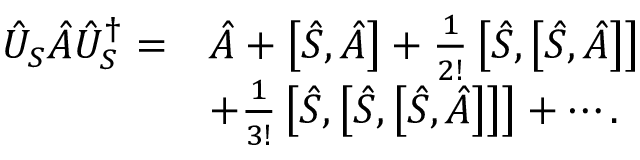Convert formula to latex. <formula><loc_0><loc_0><loc_500><loc_500>\begin{array} { r l } { \hat { U } _ { S } \hat { A } \hat { U } _ { S } ^ { \dagger } = } & { \hat { A } + \left [ \hat { S } , \hat { A } \right ] + \frac { 1 } { 2 ! } \left [ \hat { S } , \left [ \hat { S } , \hat { A } \right ] \right ] } \\ & { + \frac { 1 } { 3 ! } \left [ \hat { S } , \left [ \hat { S } , \left [ \hat { S } , \hat { A } \right ] \right ] \right ] + \cdots . } \end{array}</formula> 